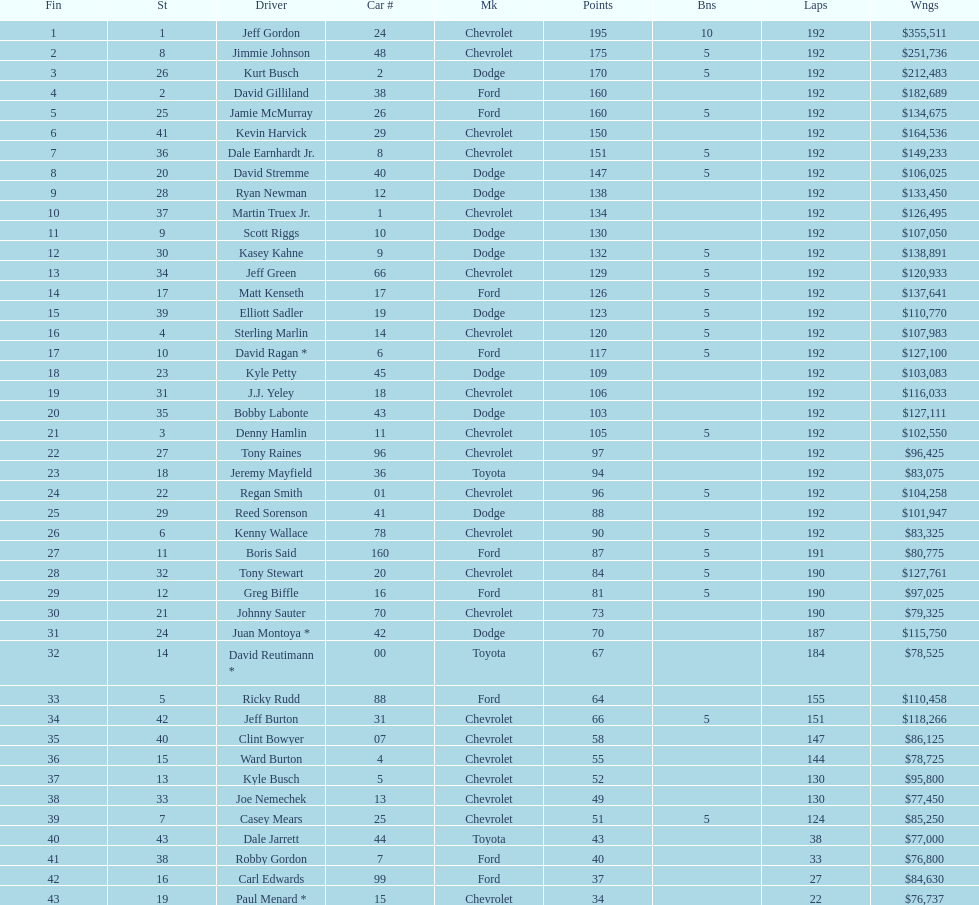How many drivers earned no bonus for this race? 23. 